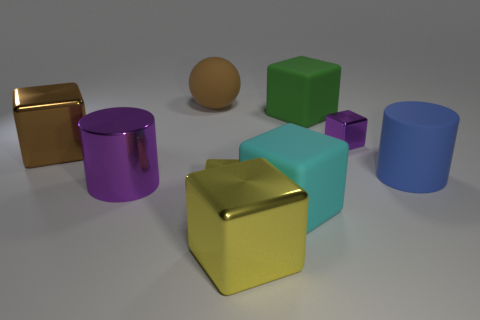Subtract 3 blocks. How many blocks are left? 3 Subtract all brown cubes. How many cubes are left? 5 Subtract all tiny metal blocks. How many blocks are left? 4 Subtract all brown cubes. Subtract all brown cylinders. How many cubes are left? 5 Subtract all blocks. How many objects are left? 3 Subtract 0 purple spheres. How many objects are left? 9 Subtract all large metal cubes. Subtract all tiny blocks. How many objects are left? 5 Add 2 cyan matte things. How many cyan matte things are left? 3 Add 9 large yellow shiny objects. How many large yellow shiny objects exist? 10 